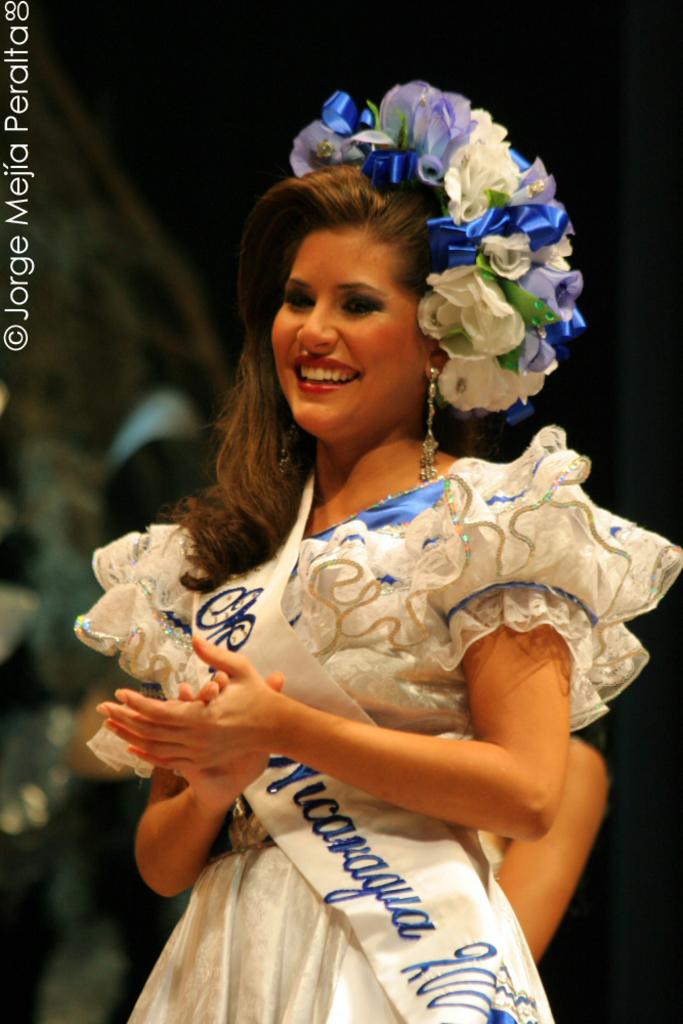What is this pageant for?
Make the answer very short. Unanswerable. 